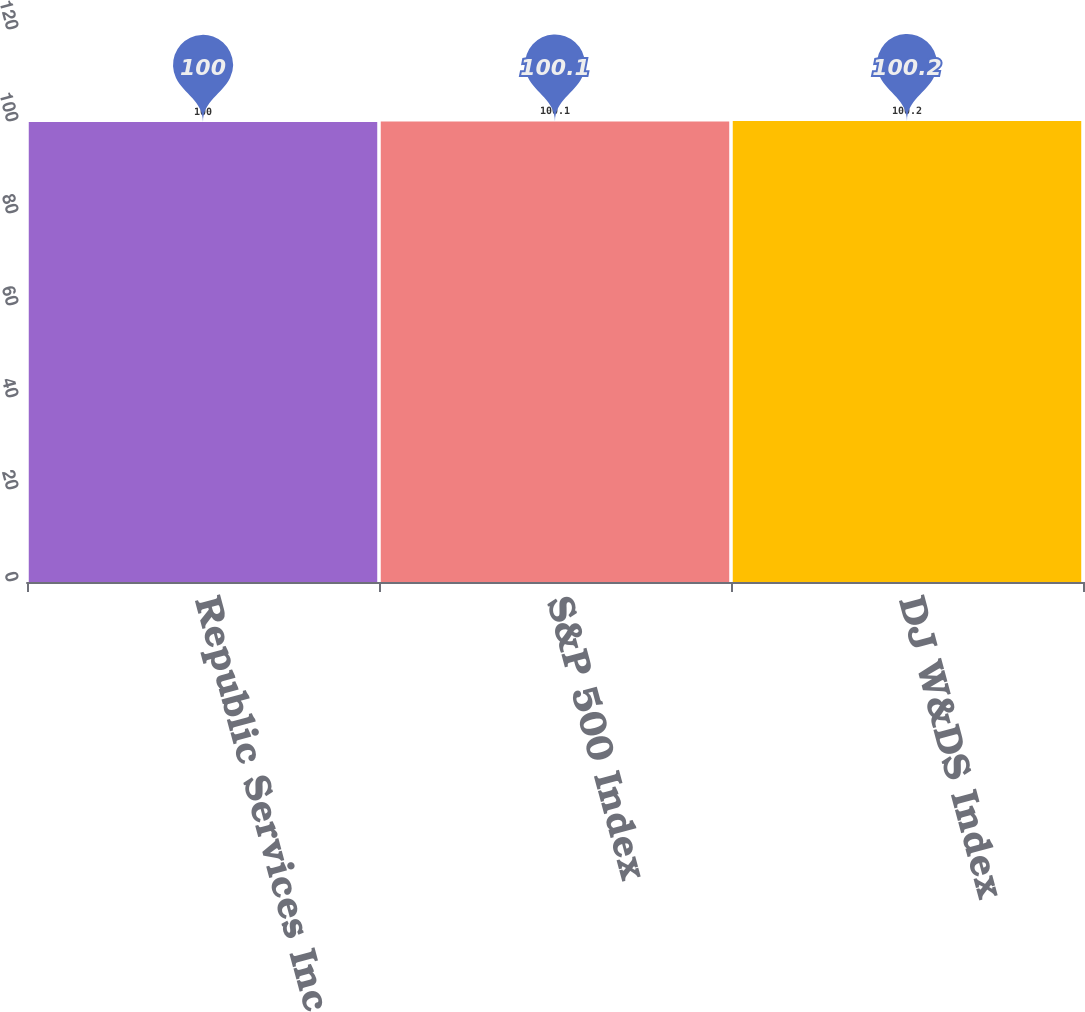<chart> <loc_0><loc_0><loc_500><loc_500><bar_chart><fcel>Republic Services Inc<fcel>S&P 500 Index<fcel>DJ W&DS Index<nl><fcel>100<fcel>100.1<fcel>100.2<nl></chart> 